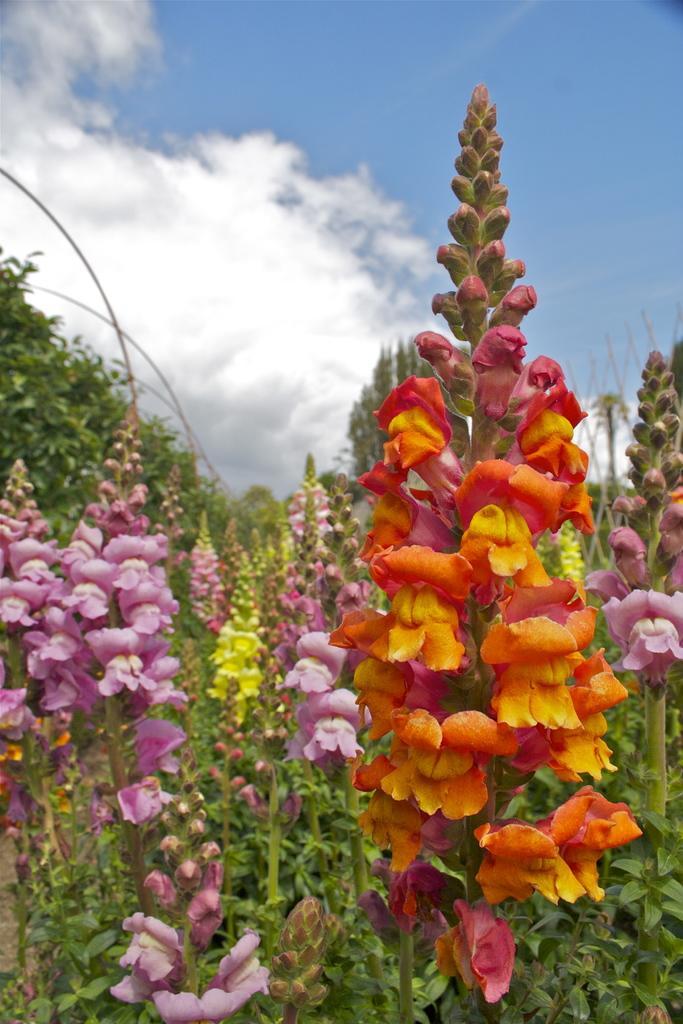Can you describe this image briefly? In this picture we can see some flowers. Sky is blue in color and cloudy. 